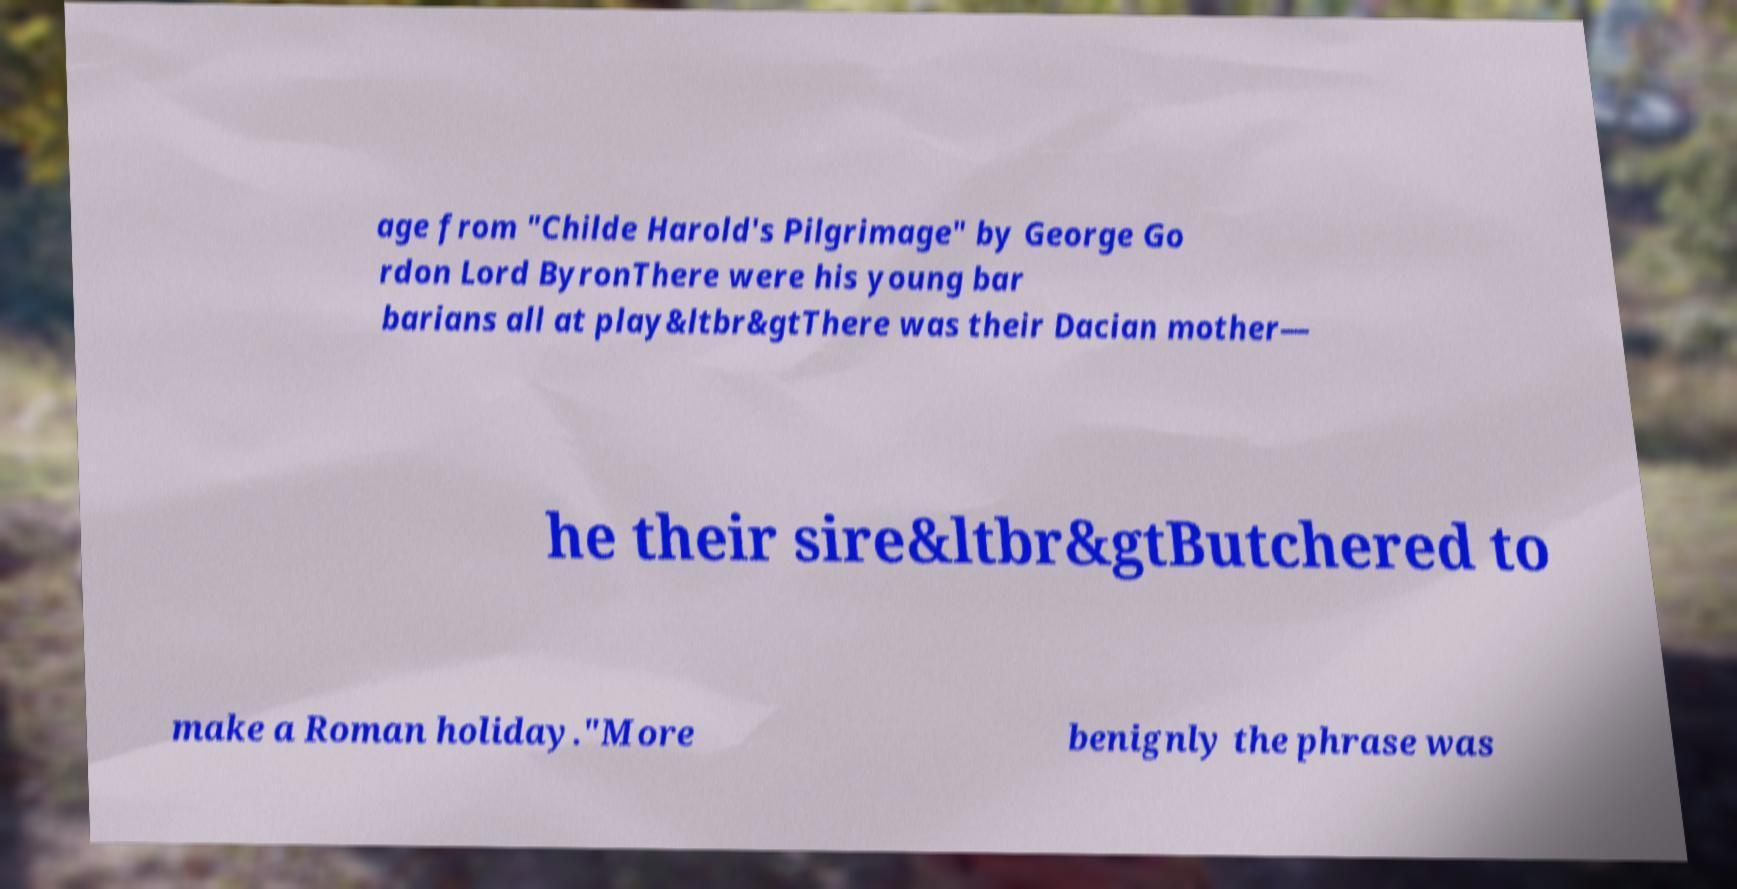Please read and relay the text visible in this image. What does it say? age from "Childe Harold's Pilgrimage" by George Go rdon Lord ByronThere were his young bar barians all at play&ltbr&gtThere was their Dacian mother— he their sire&ltbr&gtButchered to make a Roman holiday."More benignly the phrase was 